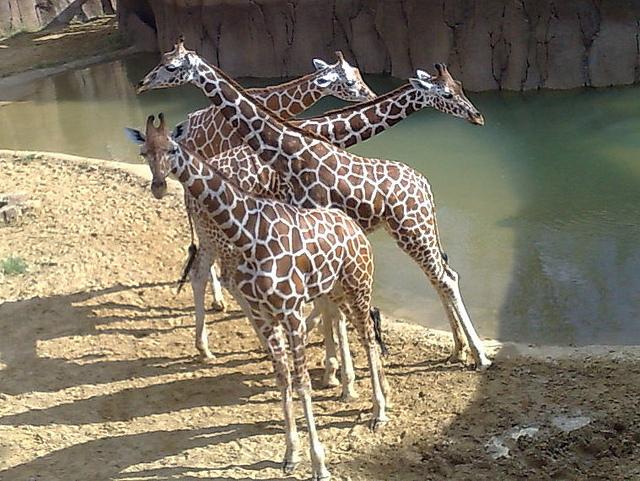What are the animals standing near?
Keep it brief. Water. Are the giraffes trying to make a pattern with their neck positions?
Be succinct. No. How many animals?
Give a very brief answer. 4. 